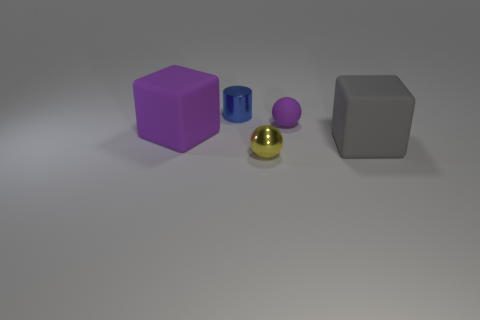How many objects are matte objects that are on the right side of the large purple rubber cube or objects in front of the gray thing?
Offer a very short reply. 3. There is a blue cylinder that is the same size as the yellow shiny ball; what material is it?
Your response must be concise. Metal. How many other objects are the same material as the gray object?
Provide a succinct answer. 2. There is a rubber thing that is on the left side of the blue cylinder; does it have the same shape as the big gray object that is in front of the small purple matte thing?
Your answer should be compact. Yes. There is a small sphere that is behind the big thing to the right of the tiny sphere that is behind the large gray cube; what color is it?
Your answer should be compact. Purple. How many other things are the same color as the cylinder?
Your response must be concise. 0. Is the number of big purple objects less than the number of small cyan cubes?
Offer a terse response. No. What is the color of the object that is both in front of the small purple matte thing and to the right of the yellow shiny sphere?
Provide a short and direct response. Gray. There is a small yellow thing that is the same shape as the tiny purple matte object; what material is it?
Keep it short and to the point. Metal. Are there more purple rubber spheres than brown balls?
Offer a terse response. Yes. 